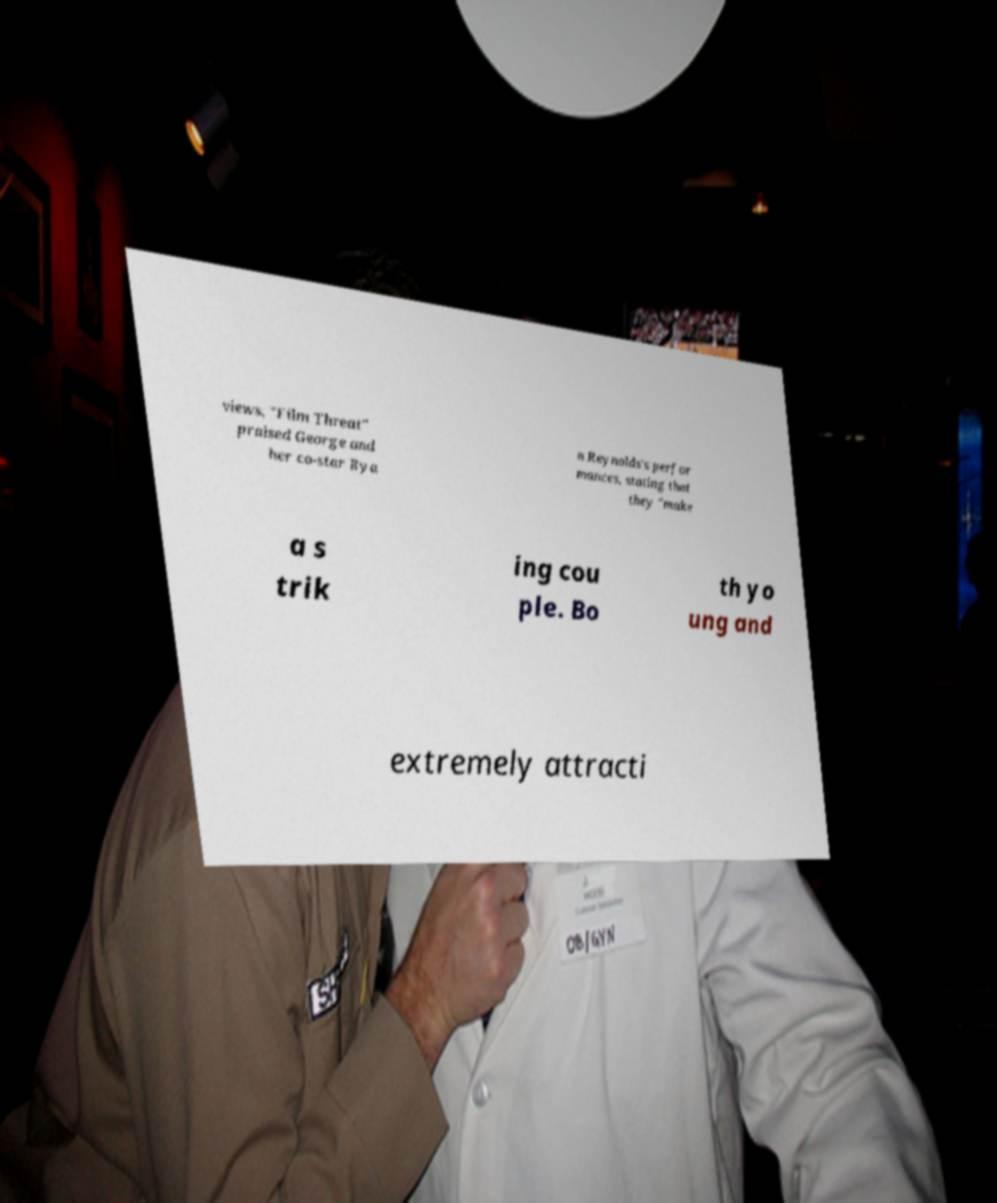Can you read and provide the text displayed in the image?This photo seems to have some interesting text. Can you extract and type it out for me? views, "Film Threat" praised George and her co-star Rya n Reynolds's perfor mances, stating that they "make a s trik ing cou ple. Bo th yo ung and extremely attracti 